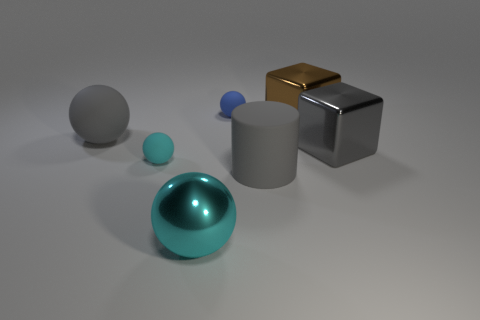Does the metallic sphere have the same size as the gray rubber thing on the left side of the small blue object?
Your response must be concise. Yes. What is the material of the big sphere in front of the gray block?
Give a very brief answer. Metal. Is the number of large gray shiny cubes on the left side of the big brown thing the same as the number of tiny purple metallic blocks?
Provide a short and direct response. Yes. Is the size of the brown metal cube the same as the blue matte sphere?
Provide a succinct answer. No. Is there a matte thing to the left of the small thing behind the big gray matte object that is behind the large gray matte cylinder?
Keep it short and to the point. Yes. There is a tiny cyan thing that is the same shape as the blue matte object; what is it made of?
Provide a succinct answer. Rubber. There is a brown object that is to the right of the blue rubber thing; how many brown blocks are right of it?
Your answer should be very brief. 0. There is a matte sphere that is on the right side of the tiny sphere that is in front of the tiny rubber thing that is behind the large brown metallic object; what size is it?
Offer a very short reply. Small. The big metallic thing that is to the left of the large gray cylinder to the left of the brown thing is what color?
Make the answer very short. Cyan. How many other things are made of the same material as the large brown thing?
Provide a short and direct response. 2. 